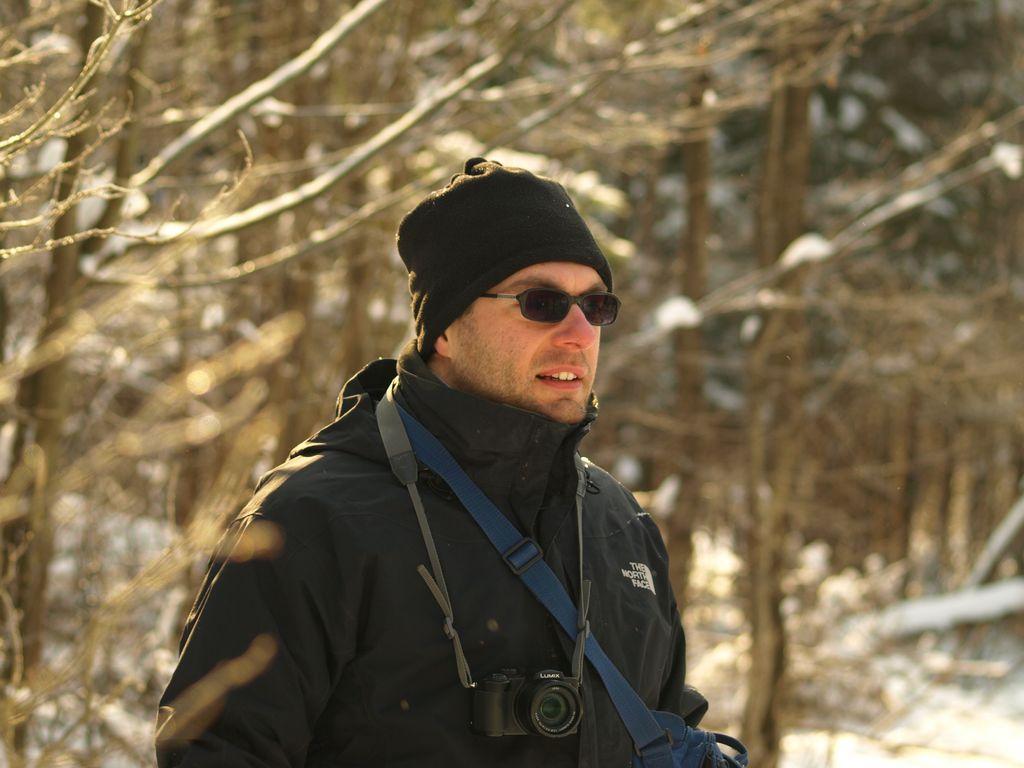In one or two sentences, can you explain what this image depicts? In this image I can see a person with cap. And there is a bag across his shoulder, also there is a camera. And in the background there are dried trees. 